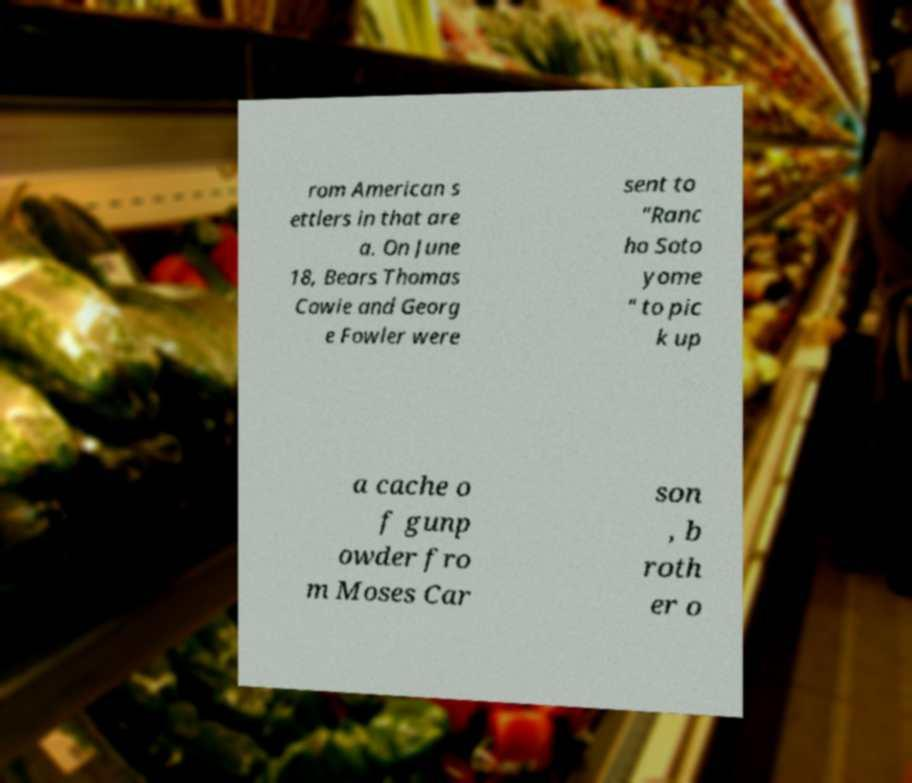Please read and relay the text visible in this image. What does it say? rom American s ettlers in that are a. On June 18, Bears Thomas Cowie and Georg e Fowler were sent to "Ranc ho Soto yome " to pic k up a cache o f gunp owder fro m Moses Car son , b roth er o 